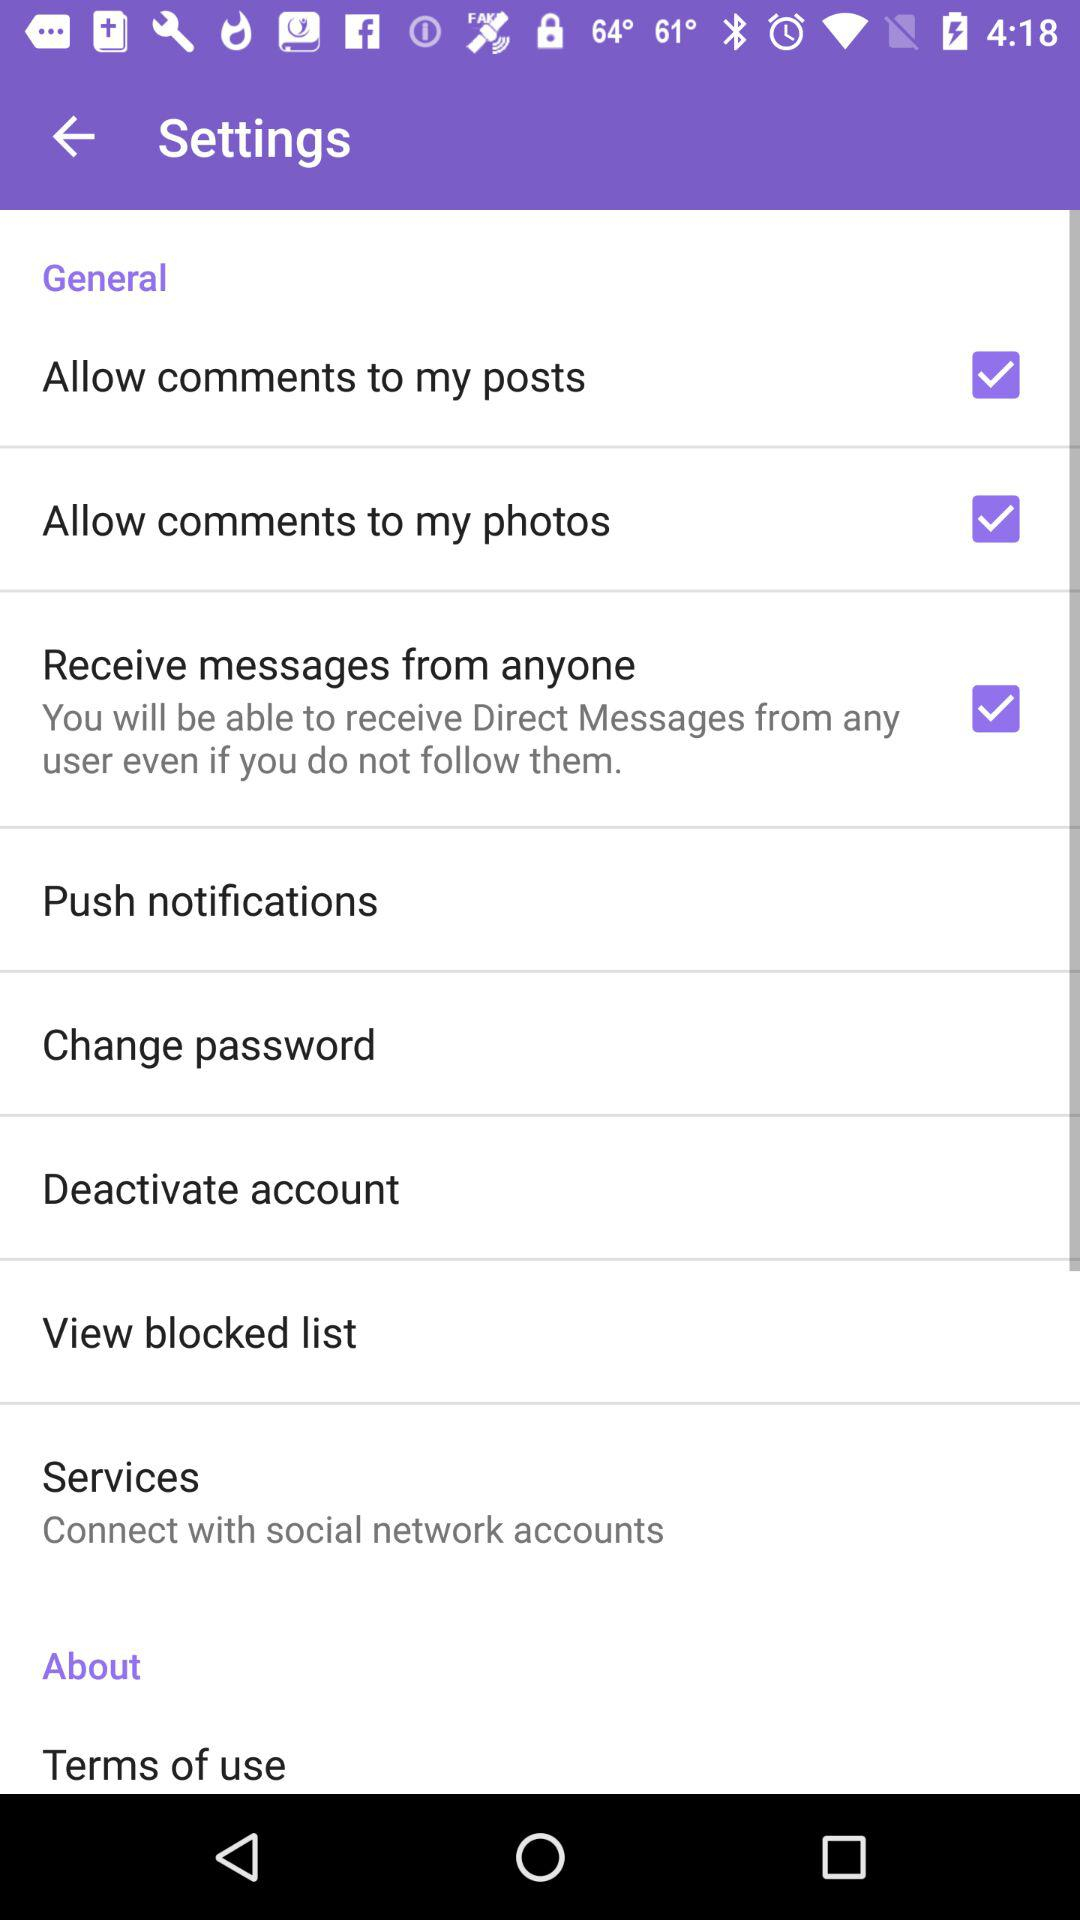How many notifications are there in "Services"?
When the provided information is insufficient, respond with <no answer>. <no answer> 